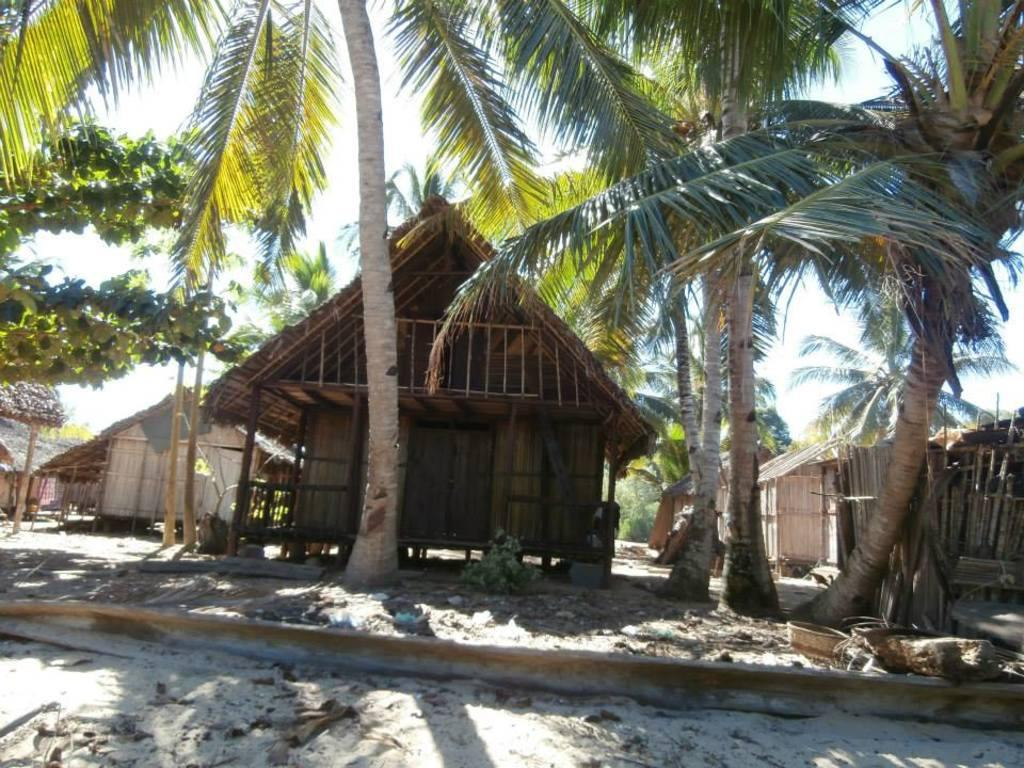What type of vegetation can be seen in the image? There are trees in the image. What type of structures are present in the image? There are huts in the image. Can you hear the bells ringing in the image? There are no bells present in the image, so it is not possible to hear them ringing. 